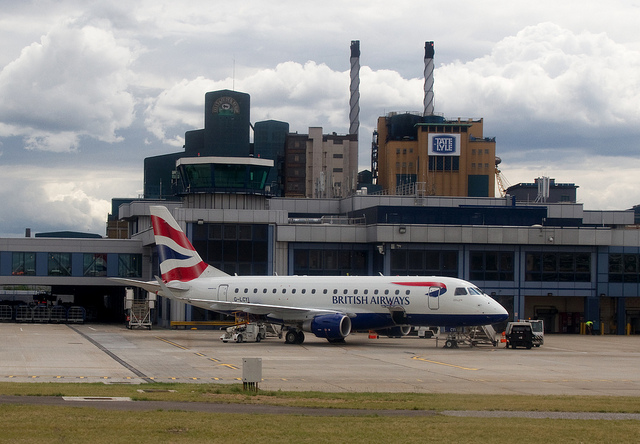What does the presence of smoke stacks imply about the location? The smokestacks suggest that this location is likely near an industrial area or power generation facility, indicating a blend of transportation and industrial functions possibly near an urban center. 